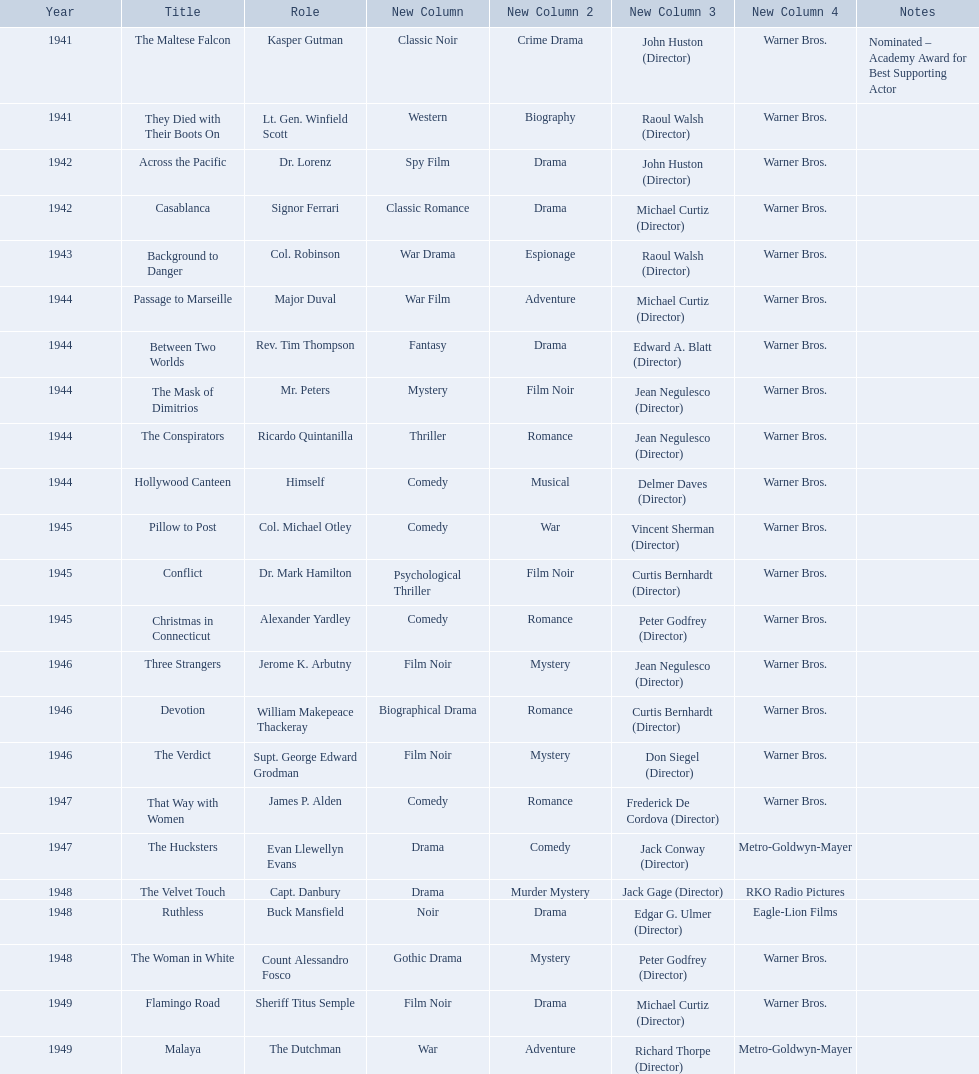What are all of the movies sydney greenstreet acted in? The Maltese Falcon, They Died with Their Boots On, Across the Pacific, Casablanca, Background to Danger, Passage to Marseille, Between Two Worlds, The Mask of Dimitrios, The Conspirators, Hollywood Canteen, Pillow to Post, Conflict, Christmas in Connecticut, Three Strangers, Devotion, The Verdict, That Way with Women, The Hucksters, The Velvet Touch, Ruthless, The Woman in White, Flamingo Road, Malaya. What are all of the title notes? Nominated – Academy Award for Best Supporting Actor. Which film was the award for? The Maltese Falcon. What year was the movie that was nominated ? 1941. What was the title of the movie? The Maltese Falcon. 